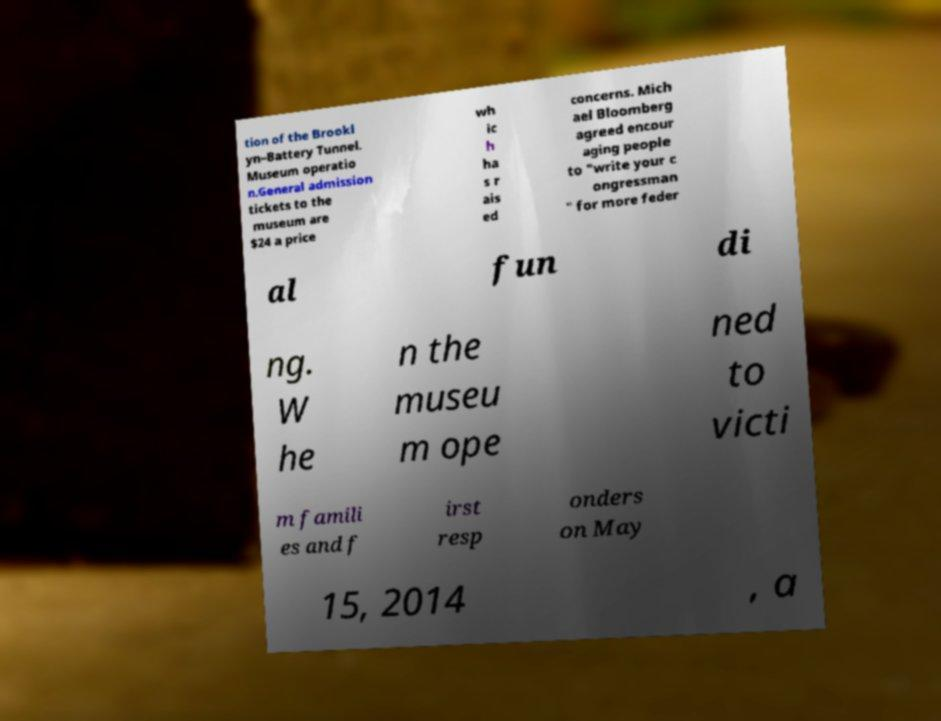Could you extract and type out the text from this image? tion of the Brookl yn–Battery Tunnel. Museum operatio n.General admission tickets to the museum are $24 a price wh ic h ha s r ais ed concerns. Mich ael Bloomberg agreed encour aging people to "write your c ongressman " for more feder al fun di ng. W he n the museu m ope ned to victi m famili es and f irst resp onders on May 15, 2014 , a 